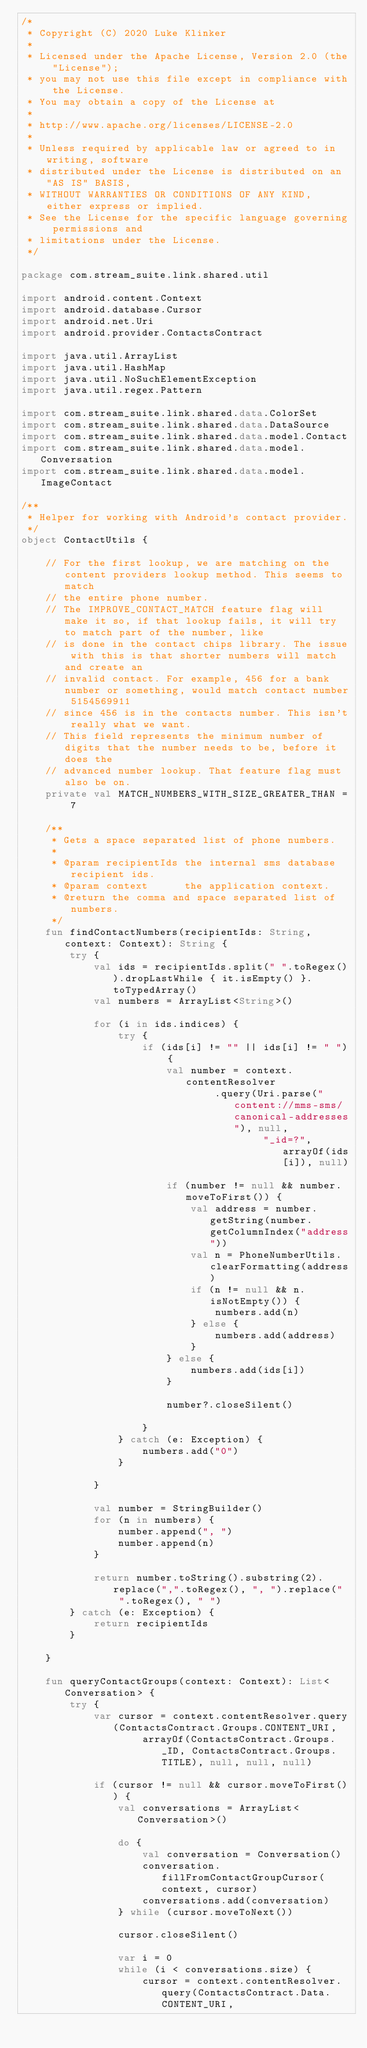<code> <loc_0><loc_0><loc_500><loc_500><_Kotlin_>/*
 * Copyright (C) 2020 Luke Klinker
 *
 * Licensed under the Apache License, Version 2.0 (the "License");
 * you may not use this file except in compliance with the License.
 * You may obtain a copy of the License at
 *
 * http://www.apache.org/licenses/LICENSE-2.0
 *
 * Unless required by applicable law or agreed to in writing, software
 * distributed under the License is distributed on an "AS IS" BASIS,
 * WITHOUT WARRANTIES OR CONDITIONS OF ANY KIND, either express or implied.
 * See the License for the specific language governing permissions and
 * limitations under the License.
 */

package com.stream_suite.link.shared.util

import android.content.Context
import android.database.Cursor
import android.net.Uri
import android.provider.ContactsContract

import java.util.ArrayList
import java.util.HashMap
import java.util.NoSuchElementException
import java.util.regex.Pattern

import com.stream_suite.link.shared.data.ColorSet
import com.stream_suite.link.shared.data.DataSource
import com.stream_suite.link.shared.data.model.Contact
import com.stream_suite.link.shared.data.model.Conversation
import com.stream_suite.link.shared.data.model.ImageContact

/**
 * Helper for working with Android's contact provider.
 */
object ContactUtils {

    // For the first lookup, we are matching on the content providers lookup method. This seems to match
    // the entire phone number.
    // The IMPROVE_CONTACT_MATCH feature flag will make it so, if that lookup fails, it will try to match part of the number, like
    // is done in the contact chips library. The issue with this is that shorter numbers will match and create an
    // invalid contact. For example, 456 for a bank number or something, would match contact number 5154569911
    // since 456 is in the contacts number. This isn't really what we want.
    // This field represents the minimum number of digits that the number needs to be, before it does the
    // advanced number lookup. That feature flag must also be on.
    private val MATCH_NUMBERS_WITH_SIZE_GREATER_THAN = 7

    /**
     * Gets a space separated list of phone numbers.
     *
     * @param recipientIds the internal sms database recipient ids.
     * @param context      the application context.
     * @return the comma and space separated list of numbers.
     */
    fun findContactNumbers(recipientIds: String, context: Context): String {
        try {
            val ids = recipientIds.split(" ".toRegex()).dropLastWhile { it.isEmpty() }.toTypedArray()
            val numbers = ArrayList<String>()

            for (i in ids.indices) {
                try {
                    if (ids[i] != "" || ids[i] != " ") {
                        val number = context.contentResolver
                                .query(Uri.parse("content://mms-sms/canonical-addresses"), null,
                                        "_id=?", arrayOf(ids[i]), null)

                        if (number != null && number.moveToFirst()) {
                            val address = number.getString(number.getColumnIndex("address"))
                            val n = PhoneNumberUtils.clearFormatting(address)
                            if (n != null && n.isNotEmpty()) {
                                numbers.add(n)
                            } else {
                                numbers.add(address)
                            }
                        } else {
                            numbers.add(ids[i])
                        }

                        number?.closeSilent()

                    }
                } catch (e: Exception) {
                    numbers.add("0")
                }

            }

            val number = StringBuilder()
            for (n in numbers) {
                number.append(", ")
                number.append(n)
            }

            return number.toString().substring(2).replace(",".toRegex(), ", ").replace("  ".toRegex(), " ")
        } catch (e: Exception) {
            return recipientIds
        }

    }

    fun queryContactGroups(context: Context): List<Conversation> {
        try {
            var cursor = context.contentResolver.query(ContactsContract.Groups.CONTENT_URI,
                    arrayOf(ContactsContract.Groups._ID, ContactsContract.Groups.TITLE), null, null, null)

            if (cursor != null && cursor.moveToFirst()) {
                val conversations = ArrayList<Conversation>()

                do {
                    val conversation = Conversation()
                    conversation.fillFromContactGroupCursor(context, cursor)
                    conversations.add(conversation)
                } while (cursor.moveToNext())

                cursor.closeSilent()

                var i = 0
                while (i < conversations.size) {
                    cursor = context.contentResolver.query(ContactsContract.Data.CONTENT_URI,</code> 